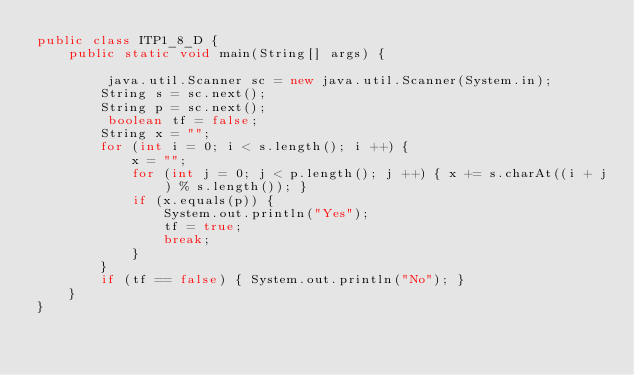Convert code to text. <code><loc_0><loc_0><loc_500><loc_500><_Java_>public class ITP1_8_D {
    public static void main(String[] args) {

         java.util.Scanner sc = new java.util.Scanner(System.in);
        String s = sc.next();
        String p = sc.next();
         boolean tf = false;
        String x = "";
        for (int i = 0; i < s.length(); i ++) {
            x = "";
            for (int j = 0; j < p.length(); j ++) { x += s.charAt((i + j) % s.length()); }
            if (x.equals(p)) {
                System.out.println("Yes");
                tf = true;
                break;
            }
        }
        if (tf == false) { System.out.println("No"); }
    }
}</code> 